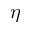Convert formula to latex. <formula><loc_0><loc_0><loc_500><loc_500>\eta</formula> 